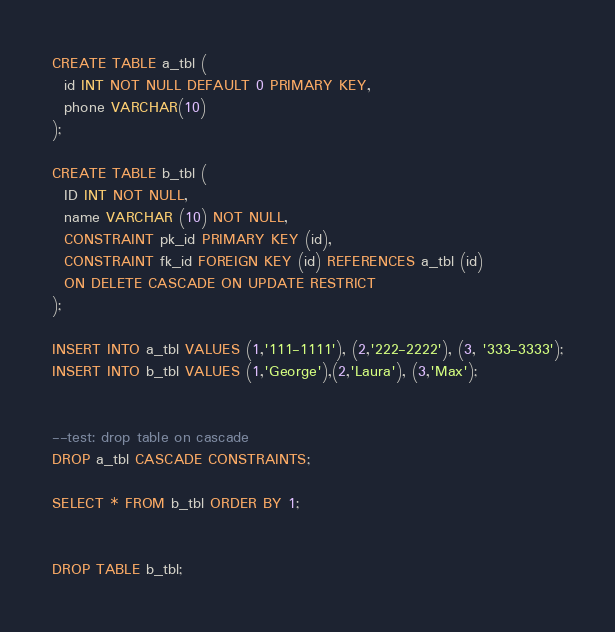Convert code to text. <code><loc_0><loc_0><loc_500><loc_500><_SQL_>
CREATE TABLE a_tbl (
  id INT NOT NULL DEFAULT 0 PRIMARY KEY,
  phone VARCHAR(10)
);

CREATE TABLE b_tbl (
  ID INT NOT NULL,
  name VARCHAR (10) NOT NULL,
  CONSTRAINT pk_id PRIMARY KEY (id),
  CONSTRAINT fk_id FOREIGN KEY (id) REFERENCES a_tbl (id)
  ON DELETE CASCADE ON UPDATE RESTRICT
);

INSERT INTO a_tbl VALUES (1,'111-1111'), (2,'222-2222'), (3, '333-3333');
INSERT INTO b_tbl VALUES (1,'George'),(2,'Laura'), (3,'Max');


--test: drop table on cascade
DROP a_tbl CASCADE CONSTRAINTS;

SELECT * FROM b_tbl ORDER BY 1;


DROP TABLE b_tbl;
</code> 